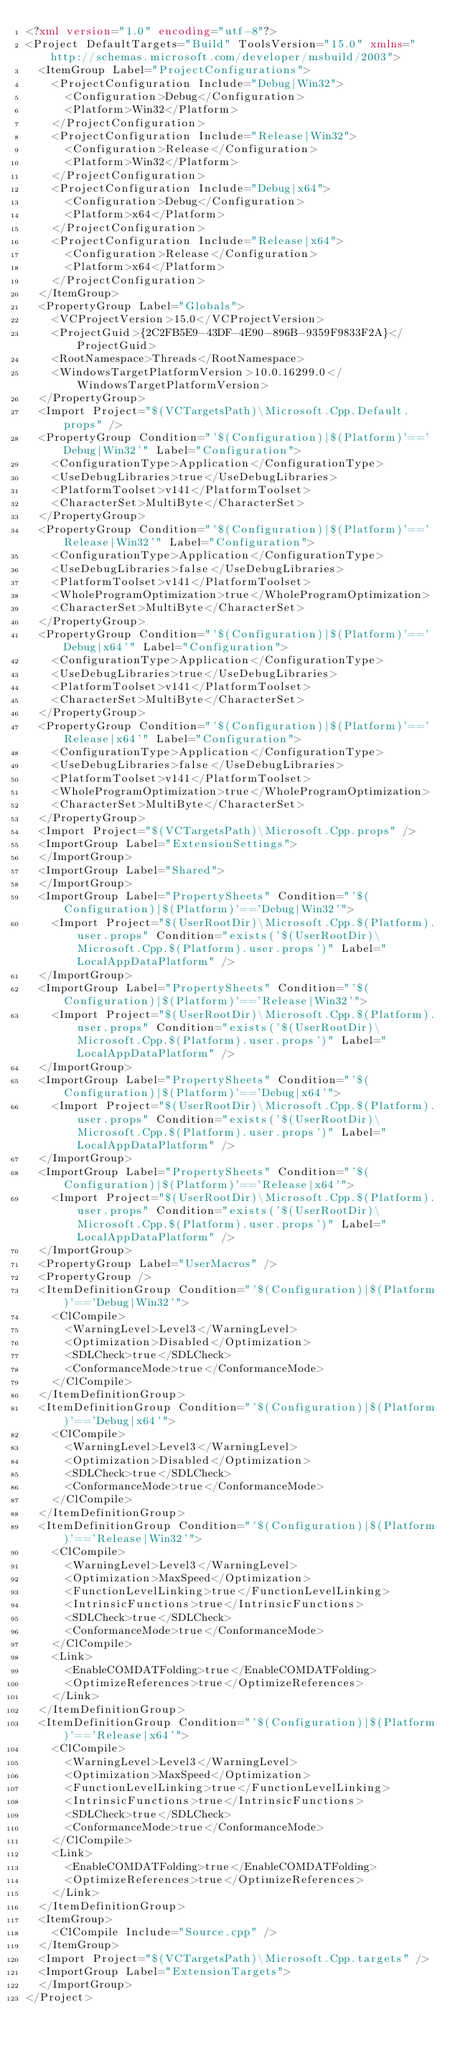Convert code to text. <code><loc_0><loc_0><loc_500><loc_500><_XML_><?xml version="1.0" encoding="utf-8"?>
<Project DefaultTargets="Build" ToolsVersion="15.0" xmlns="http://schemas.microsoft.com/developer/msbuild/2003">
  <ItemGroup Label="ProjectConfigurations">
    <ProjectConfiguration Include="Debug|Win32">
      <Configuration>Debug</Configuration>
      <Platform>Win32</Platform>
    </ProjectConfiguration>
    <ProjectConfiguration Include="Release|Win32">
      <Configuration>Release</Configuration>
      <Platform>Win32</Platform>
    </ProjectConfiguration>
    <ProjectConfiguration Include="Debug|x64">
      <Configuration>Debug</Configuration>
      <Platform>x64</Platform>
    </ProjectConfiguration>
    <ProjectConfiguration Include="Release|x64">
      <Configuration>Release</Configuration>
      <Platform>x64</Platform>
    </ProjectConfiguration>
  </ItemGroup>
  <PropertyGroup Label="Globals">
    <VCProjectVersion>15.0</VCProjectVersion>
    <ProjectGuid>{2C2FB5E9-43DF-4E90-896B-9359F9833F2A}</ProjectGuid>
    <RootNamespace>Threads</RootNamespace>
    <WindowsTargetPlatformVersion>10.0.16299.0</WindowsTargetPlatformVersion>
  </PropertyGroup>
  <Import Project="$(VCTargetsPath)\Microsoft.Cpp.Default.props" />
  <PropertyGroup Condition="'$(Configuration)|$(Platform)'=='Debug|Win32'" Label="Configuration">
    <ConfigurationType>Application</ConfigurationType>
    <UseDebugLibraries>true</UseDebugLibraries>
    <PlatformToolset>v141</PlatformToolset>
    <CharacterSet>MultiByte</CharacterSet>
  </PropertyGroup>
  <PropertyGroup Condition="'$(Configuration)|$(Platform)'=='Release|Win32'" Label="Configuration">
    <ConfigurationType>Application</ConfigurationType>
    <UseDebugLibraries>false</UseDebugLibraries>
    <PlatformToolset>v141</PlatformToolset>
    <WholeProgramOptimization>true</WholeProgramOptimization>
    <CharacterSet>MultiByte</CharacterSet>
  </PropertyGroup>
  <PropertyGroup Condition="'$(Configuration)|$(Platform)'=='Debug|x64'" Label="Configuration">
    <ConfigurationType>Application</ConfigurationType>
    <UseDebugLibraries>true</UseDebugLibraries>
    <PlatformToolset>v141</PlatformToolset>
    <CharacterSet>MultiByte</CharacterSet>
  </PropertyGroup>
  <PropertyGroup Condition="'$(Configuration)|$(Platform)'=='Release|x64'" Label="Configuration">
    <ConfigurationType>Application</ConfigurationType>
    <UseDebugLibraries>false</UseDebugLibraries>
    <PlatformToolset>v141</PlatformToolset>
    <WholeProgramOptimization>true</WholeProgramOptimization>
    <CharacterSet>MultiByte</CharacterSet>
  </PropertyGroup>
  <Import Project="$(VCTargetsPath)\Microsoft.Cpp.props" />
  <ImportGroup Label="ExtensionSettings">
  </ImportGroup>
  <ImportGroup Label="Shared">
  </ImportGroup>
  <ImportGroup Label="PropertySheets" Condition="'$(Configuration)|$(Platform)'=='Debug|Win32'">
    <Import Project="$(UserRootDir)\Microsoft.Cpp.$(Platform).user.props" Condition="exists('$(UserRootDir)\Microsoft.Cpp.$(Platform).user.props')" Label="LocalAppDataPlatform" />
  </ImportGroup>
  <ImportGroup Label="PropertySheets" Condition="'$(Configuration)|$(Platform)'=='Release|Win32'">
    <Import Project="$(UserRootDir)\Microsoft.Cpp.$(Platform).user.props" Condition="exists('$(UserRootDir)\Microsoft.Cpp.$(Platform).user.props')" Label="LocalAppDataPlatform" />
  </ImportGroup>
  <ImportGroup Label="PropertySheets" Condition="'$(Configuration)|$(Platform)'=='Debug|x64'">
    <Import Project="$(UserRootDir)\Microsoft.Cpp.$(Platform).user.props" Condition="exists('$(UserRootDir)\Microsoft.Cpp.$(Platform).user.props')" Label="LocalAppDataPlatform" />
  </ImportGroup>
  <ImportGroup Label="PropertySheets" Condition="'$(Configuration)|$(Platform)'=='Release|x64'">
    <Import Project="$(UserRootDir)\Microsoft.Cpp.$(Platform).user.props" Condition="exists('$(UserRootDir)\Microsoft.Cpp.$(Platform).user.props')" Label="LocalAppDataPlatform" />
  </ImportGroup>
  <PropertyGroup Label="UserMacros" />
  <PropertyGroup />
  <ItemDefinitionGroup Condition="'$(Configuration)|$(Platform)'=='Debug|Win32'">
    <ClCompile>
      <WarningLevel>Level3</WarningLevel>
      <Optimization>Disabled</Optimization>
      <SDLCheck>true</SDLCheck>
      <ConformanceMode>true</ConformanceMode>
    </ClCompile>
  </ItemDefinitionGroup>
  <ItemDefinitionGroup Condition="'$(Configuration)|$(Platform)'=='Debug|x64'">
    <ClCompile>
      <WarningLevel>Level3</WarningLevel>
      <Optimization>Disabled</Optimization>
      <SDLCheck>true</SDLCheck>
      <ConformanceMode>true</ConformanceMode>
    </ClCompile>
  </ItemDefinitionGroup>
  <ItemDefinitionGroup Condition="'$(Configuration)|$(Platform)'=='Release|Win32'">
    <ClCompile>
      <WarningLevel>Level3</WarningLevel>
      <Optimization>MaxSpeed</Optimization>
      <FunctionLevelLinking>true</FunctionLevelLinking>
      <IntrinsicFunctions>true</IntrinsicFunctions>
      <SDLCheck>true</SDLCheck>
      <ConformanceMode>true</ConformanceMode>
    </ClCompile>
    <Link>
      <EnableCOMDATFolding>true</EnableCOMDATFolding>
      <OptimizeReferences>true</OptimizeReferences>
    </Link>
  </ItemDefinitionGroup>
  <ItemDefinitionGroup Condition="'$(Configuration)|$(Platform)'=='Release|x64'">
    <ClCompile>
      <WarningLevel>Level3</WarningLevel>
      <Optimization>MaxSpeed</Optimization>
      <FunctionLevelLinking>true</FunctionLevelLinking>
      <IntrinsicFunctions>true</IntrinsicFunctions>
      <SDLCheck>true</SDLCheck>
      <ConformanceMode>true</ConformanceMode>
    </ClCompile>
    <Link>
      <EnableCOMDATFolding>true</EnableCOMDATFolding>
      <OptimizeReferences>true</OptimizeReferences>
    </Link>
  </ItemDefinitionGroup>
  <ItemGroup>
    <ClCompile Include="Source.cpp" />
  </ItemGroup>
  <Import Project="$(VCTargetsPath)\Microsoft.Cpp.targets" />
  <ImportGroup Label="ExtensionTargets">
  </ImportGroup>
</Project></code> 